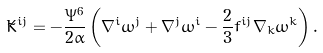Convert formula to latex. <formula><loc_0><loc_0><loc_500><loc_500>\tilde { K } ^ { i j } = - \frac { \Psi ^ { 6 } } { 2 \alpha } \left ( \nabla ^ { i } \omega ^ { j } + \nabla ^ { j } \omega ^ { i } - \frac { 2 } { 3 } f ^ { i j } \nabla _ { k } \omega ^ { k } \right ) .</formula> 